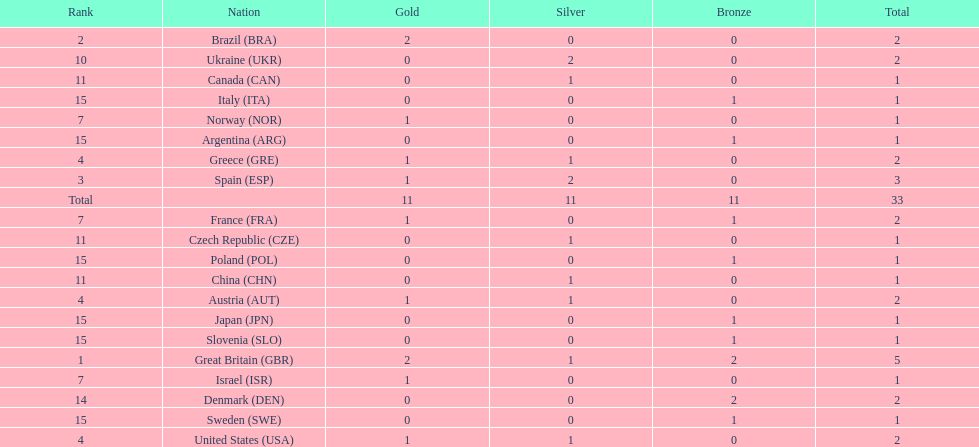How many countries won at least 1 gold and 1 silver medal? 5. Parse the table in full. {'header': ['Rank', 'Nation', 'Gold', 'Silver', 'Bronze', 'Total'], 'rows': [['2', 'Brazil\xa0(BRA)', '2', '0', '0', '2'], ['10', 'Ukraine\xa0(UKR)', '0', '2', '0', '2'], ['11', 'Canada\xa0(CAN)', '0', '1', '0', '1'], ['15', 'Italy\xa0(ITA)', '0', '0', '1', '1'], ['7', 'Norway\xa0(NOR)', '1', '0', '0', '1'], ['15', 'Argentina\xa0(ARG)', '0', '0', '1', '1'], ['4', 'Greece\xa0(GRE)', '1', '1', '0', '2'], ['3', 'Spain\xa0(ESP)', '1', '2', '0', '3'], ['Total', '', '11', '11', '11', '33'], ['7', 'France\xa0(FRA)', '1', '0', '1', '2'], ['11', 'Czech Republic\xa0(CZE)', '0', '1', '0', '1'], ['15', 'Poland\xa0(POL)', '0', '0', '1', '1'], ['11', 'China\xa0(CHN)', '0', '1', '0', '1'], ['4', 'Austria\xa0(AUT)', '1', '1', '0', '2'], ['15', 'Japan\xa0(JPN)', '0', '0', '1', '1'], ['15', 'Slovenia\xa0(SLO)', '0', '0', '1', '1'], ['1', 'Great Britain\xa0(GBR)', '2', '1', '2', '5'], ['7', 'Israel\xa0(ISR)', '1', '0', '0', '1'], ['14', 'Denmark\xa0(DEN)', '0', '0', '2', '2'], ['15', 'Sweden\xa0(SWE)', '0', '0', '1', '1'], ['4', 'United States\xa0(USA)', '1', '1', '0', '2']]} 